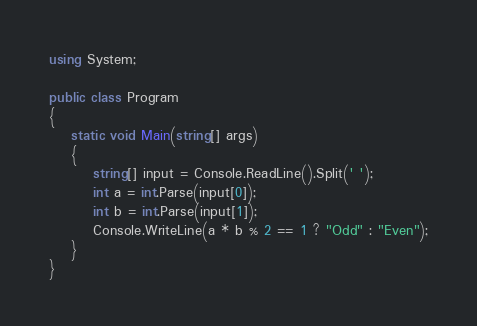Convert code to text. <code><loc_0><loc_0><loc_500><loc_500><_C#_>using System;

public class Program
{
    static void Main(string[] args)
    {
        string[] input = Console.ReadLine().Split(' ');
        int a = int.Parse(input[0]);
        int b = int.Parse(input[1]);
        Console.WriteLine(a * b % 2 == 1 ? "Odd" : "Even");
    }
}</code> 